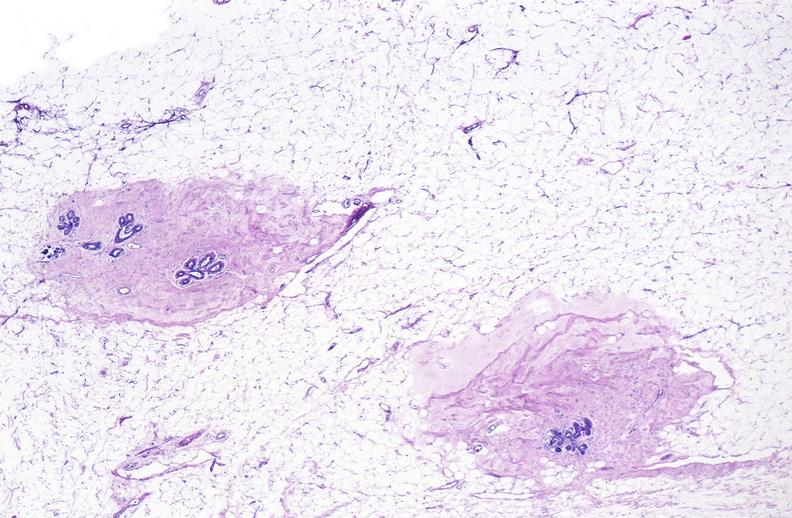where is this area in the body?
Answer the question using a single word or phrase. Breast 